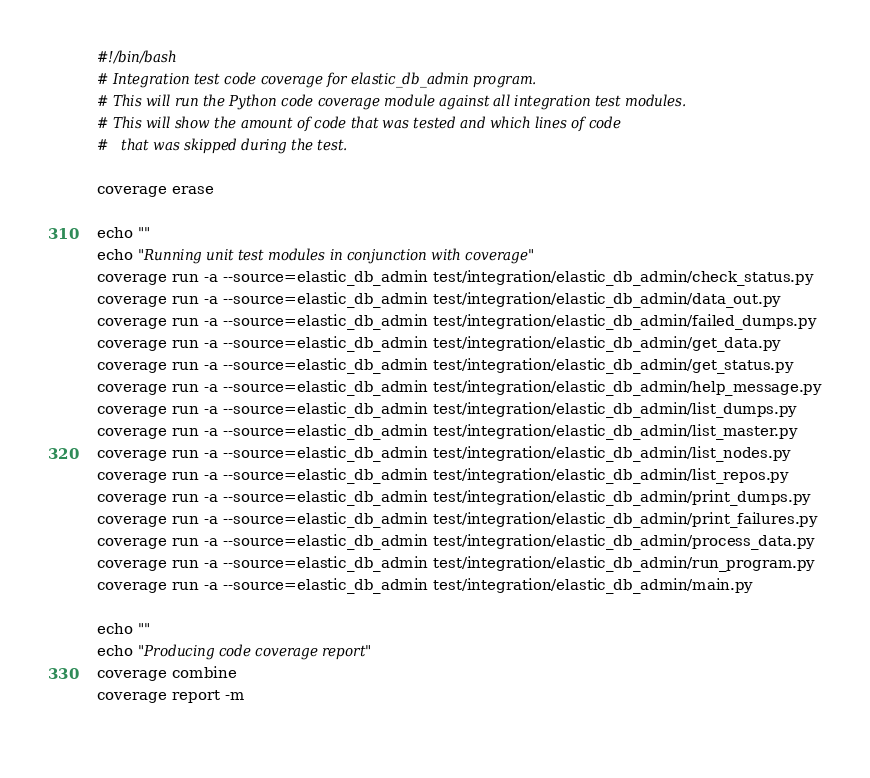<code> <loc_0><loc_0><loc_500><loc_500><_Bash_>#!/bin/bash
# Integration test code coverage for elastic_db_admin program.
# This will run the Python code coverage module against all integration test modules.
# This will show the amount of code that was tested and which lines of code
#	that was skipped during the test.

coverage erase

echo ""
echo "Running unit test modules in conjunction with coverage"
coverage run -a --source=elastic_db_admin test/integration/elastic_db_admin/check_status.py
coverage run -a --source=elastic_db_admin test/integration/elastic_db_admin/data_out.py
coverage run -a --source=elastic_db_admin test/integration/elastic_db_admin/failed_dumps.py
coverage run -a --source=elastic_db_admin test/integration/elastic_db_admin/get_data.py
coverage run -a --source=elastic_db_admin test/integration/elastic_db_admin/get_status.py
coverage run -a --source=elastic_db_admin test/integration/elastic_db_admin/help_message.py
coverage run -a --source=elastic_db_admin test/integration/elastic_db_admin/list_dumps.py
coverage run -a --source=elastic_db_admin test/integration/elastic_db_admin/list_master.py
coverage run -a --source=elastic_db_admin test/integration/elastic_db_admin/list_nodes.py
coverage run -a --source=elastic_db_admin test/integration/elastic_db_admin/list_repos.py
coverage run -a --source=elastic_db_admin test/integration/elastic_db_admin/print_dumps.py
coverage run -a --source=elastic_db_admin test/integration/elastic_db_admin/print_failures.py
coverage run -a --source=elastic_db_admin test/integration/elastic_db_admin/process_data.py
coverage run -a --source=elastic_db_admin test/integration/elastic_db_admin/run_program.py
coverage run -a --source=elastic_db_admin test/integration/elastic_db_admin/main.py

echo ""
echo "Producing code coverage report"
coverage combine
coverage report -m
 
</code> 